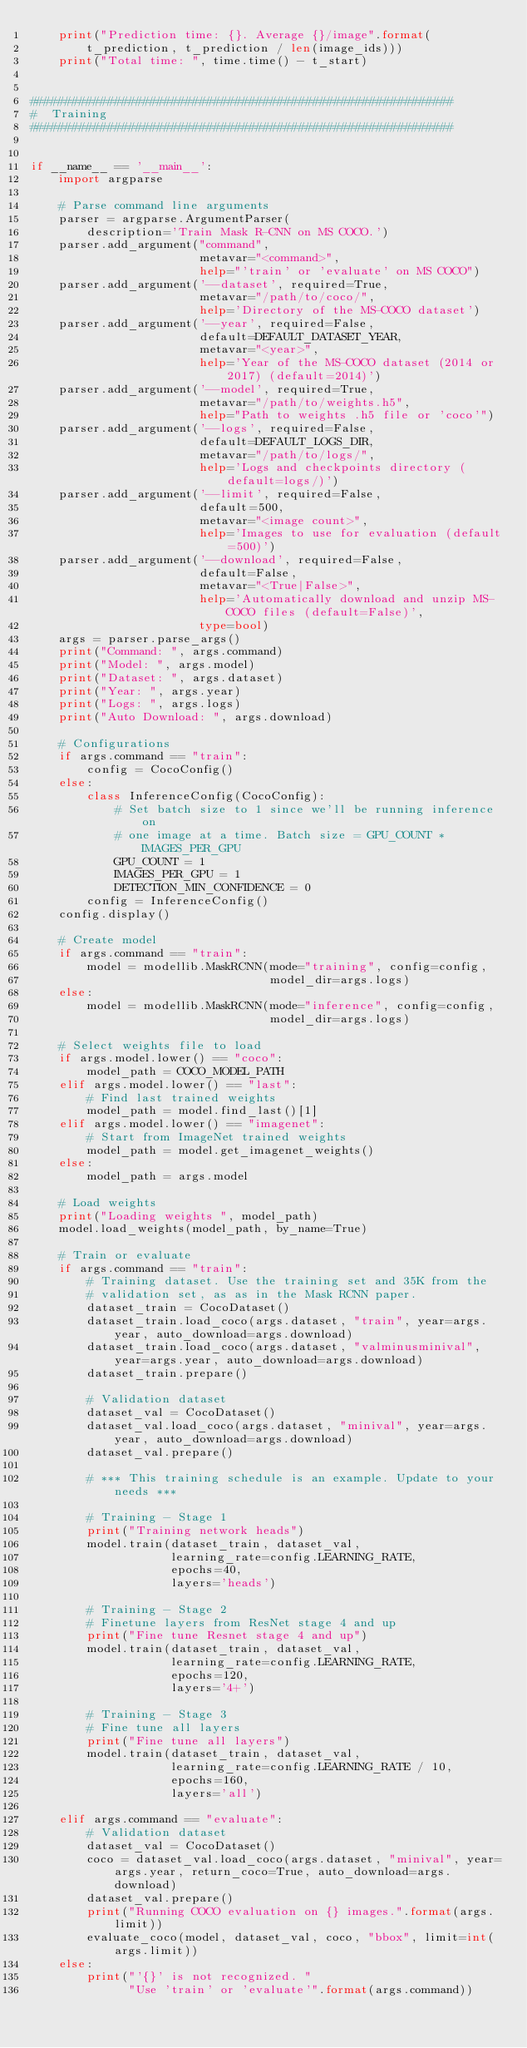Convert code to text. <code><loc_0><loc_0><loc_500><loc_500><_Python_>    print("Prediction time: {}. Average {}/image".format(
        t_prediction, t_prediction / len(image_ids)))
    print("Total time: ", time.time() - t_start)


############################################################
#  Training
############################################################


if __name__ == '__main__':
    import argparse

    # Parse command line arguments
    parser = argparse.ArgumentParser(
        description='Train Mask R-CNN on MS COCO.')
    parser.add_argument("command",
                        metavar="<command>",
                        help="'train' or 'evaluate' on MS COCO")
    parser.add_argument('--dataset', required=True,
                        metavar="/path/to/coco/",
                        help='Directory of the MS-COCO dataset')
    parser.add_argument('--year', required=False,
                        default=DEFAULT_DATASET_YEAR,
                        metavar="<year>",
                        help='Year of the MS-COCO dataset (2014 or 2017) (default=2014)')
    parser.add_argument('--model', required=True,
                        metavar="/path/to/weights.h5",
                        help="Path to weights .h5 file or 'coco'")
    parser.add_argument('--logs', required=False,
                        default=DEFAULT_LOGS_DIR,
                        metavar="/path/to/logs/",
                        help='Logs and checkpoints directory (default=logs/)')
    parser.add_argument('--limit', required=False,
                        default=500,
                        metavar="<image count>",
                        help='Images to use for evaluation (default=500)')
    parser.add_argument('--download', required=False,
                        default=False,
                        metavar="<True|False>",
                        help='Automatically download and unzip MS-COCO files (default=False)',
                        type=bool)
    args = parser.parse_args()
    print("Command: ", args.command)
    print("Model: ", args.model)
    print("Dataset: ", args.dataset)
    print("Year: ", args.year)
    print("Logs: ", args.logs)
    print("Auto Download: ", args.download)

    # Configurations
    if args.command == "train":
        config = CocoConfig()
    else:
        class InferenceConfig(CocoConfig):
            # Set batch size to 1 since we'll be running inference on
            # one image at a time. Batch size = GPU_COUNT * IMAGES_PER_GPU
            GPU_COUNT = 1
            IMAGES_PER_GPU = 1
            DETECTION_MIN_CONFIDENCE = 0
        config = InferenceConfig()
    config.display()

    # Create model
    if args.command == "train":
        model = modellib.MaskRCNN(mode="training", config=config,
                                  model_dir=args.logs)
    else:
        model = modellib.MaskRCNN(mode="inference", config=config,
                                  model_dir=args.logs)

    # Select weights file to load
    if args.model.lower() == "coco":
        model_path = COCO_MODEL_PATH
    elif args.model.lower() == "last":
        # Find last trained weights
        model_path = model.find_last()[1]
    elif args.model.lower() == "imagenet":
        # Start from ImageNet trained weights
        model_path = model.get_imagenet_weights()
    else:
        model_path = args.model

    # Load weights
    print("Loading weights ", model_path)
    model.load_weights(model_path, by_name=True)

    # Train or evaluate
    if args.command == "train":
        # Training dataset. Use the training set and 35K from the
        # validation set, as as in the Mask RCNN paper.
        dataset_train = CocoDataset()
        dataset_train.load_coco(args.dataset, "train", year=args.year, auto_download=args.download)
        dataset_train.load_coco(args.dataset, "valminusminival", year=args.year, auto_download=args.download)
        dataset_train.prepare()

        # Validation dataset
        dataset_val = CocoDataset()
        dataset_val.load_coco(args.dataset, "minival", year=args.year, auto_download=args.download)
        dataset_val.prepare()

        # *** This training schedule is an example. Update to your needs ***

        # Training - Stage 1
        print("Training network heads")
        model.train(dataset_train, dataset_val,
                    learning_rate=config.LEARNING_RATE,
                    epochs=40,
                    layers='heads')

        # Training - Stage 2
        # Finetune layers from ResNet stage 4 and up
        print("Fine tune Resnet stage 4 and up")
        model.train(dataset_train, dataset_val,
                    learning_rate=config.LEARNING_RATE,
                    epochs=120,
                    layers='4+')

        # Training - Stage 3
        # Fine tune all layers
        print("Fine tune all layers")
        model.train(dataset_train, dataset_val,
                    learning_rate=config.LEARNING_RATE / 10,
                    epochs=160,
                    layers='all')

    elif args.command == "evaluate":
        # Validation dataset
        dataset_val = CocoDataset()
        coco = dataset_val.load_coco(args.dataset, "minival", year=args.year, return_coco=True, auto_download=args.download)
        dataset_val.prepare()
        print("Running COCO evaluation on {} images.".format(args.limit))
        evaluate_coco(model, dataset_val, coco, "bbox", limit=int(args.limit))
    else:
        print("'{}' is not recognized. "
              "Use 'train' or 'evaluate'".format(args.command))
</code> 